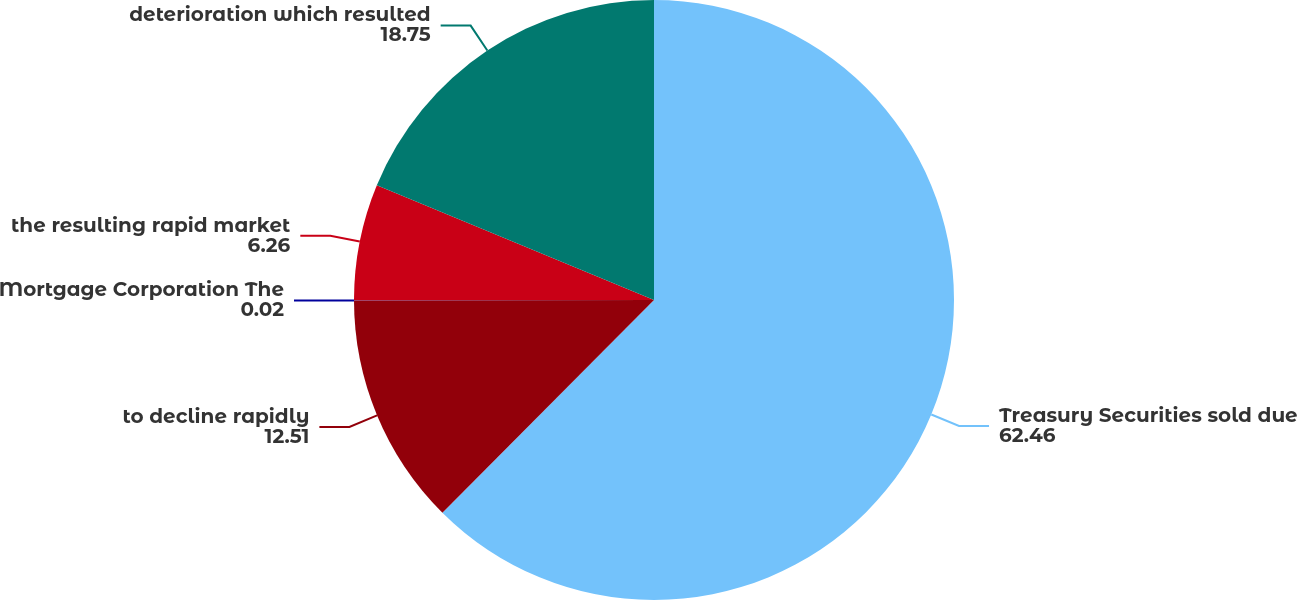<chart> <loc_0><loc_0><loc_500><loc_500><pie_chart><fcel>Treasury Securities sold due<fcel>to decline rapidly<fcel>Mortgage Corporation The<fcel>the resulting rapid market<fcel>deterioration which resulted<nl><fcel>62.46%<fcel>12.51%<fcel>0.02%<fcel>6.26%<fcel>18.75%<nl></chart> 